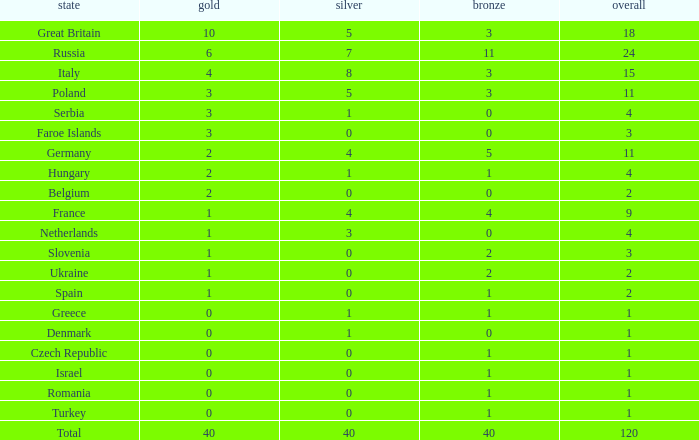Parse the table in full. {'header': ['state', 'gold', 'silver', 'bronze', 'overall'], 'rows': [['Great Britain', '10', '5', '3', '18'], ['Russia', '6', '7', '11', '24'], ['Italy', '4', '8', '3', '15'], ['Poland', '3', '5', '3', '11'], ['Serbia', '3', '1', '0', '4'], ['Faroe Islands', '3', '0', '0', '3'], ['Germany', '2', '4', '5', '11'], ['Hungary', '2', '1', '1', '4'], ['Belgium', '2', '0', '0', '2'], ['France', '1', '4', '4', '9'], ['Netherlands', '1', '3', '0', '4'], ['Slovenia', '1', '0', '2', '3'], ['Ukraine', '1', '0', '2', '2'], ['Spain', '1', '0', '1', '2'], ['Greece', '0', '1', '1', '1'], ['Denmark', '0', '1', '0', '1'], ['Czech Republic', '0', '0', '1', '1'], ['Israel', '0', '0', '1', '1'], ['Romania', '0', '0', '1', '1'], ['Turkey', '0', '0', '1', '1'], ['Total', '40', '40', '40', '120']]} What is turkey's mean gold entry that also has a bronze entry less than 2 and the total exceeds 1? None. 